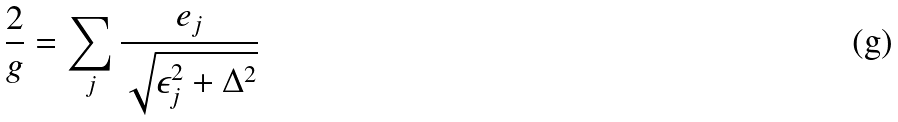<formula> <loc_0><loc_0><loc_500><loc_500>\frac { 2 } { g } = \sum _ { j } \frac { e _ { j } } { \sqrt { \epsilon _ { j } ^ { 2 } + \Delta ^ { 2 } } }</formula> 